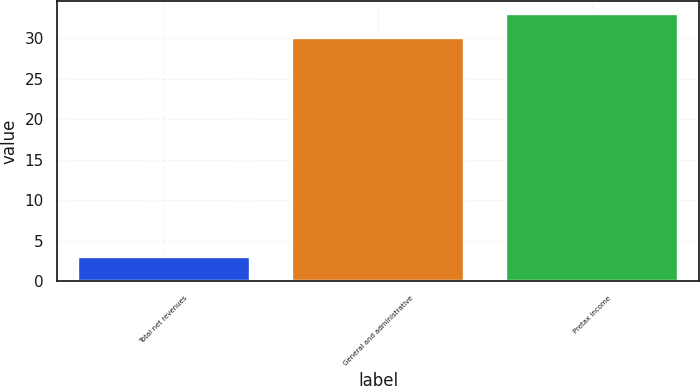Convert chart to OTSL. <chart><loc_0><loc_0><loc_500><loc_500><bar_chart><fcel>Total net revenues<fcel>General and administrative<fcel>Pretax income<nl><fcel>3<fcel>30<fcel>33<nl></chart> 